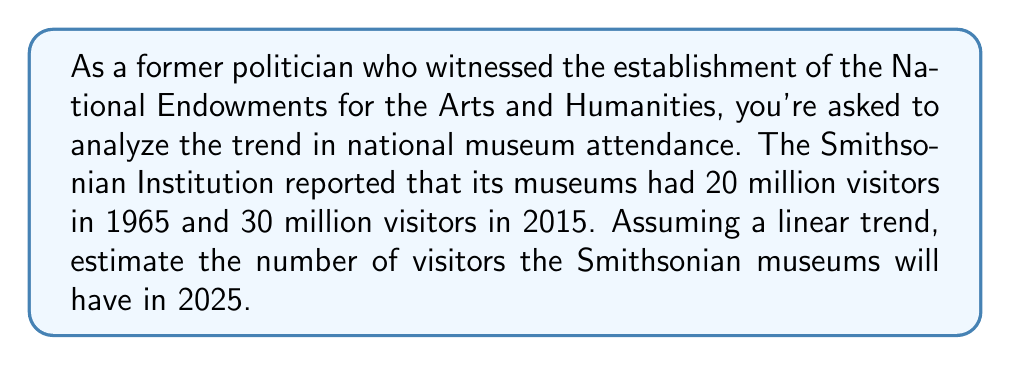Show me your answer to this math problem. To solve this problem, we'll use a linear equation to model the trend in museum attendance over time. Let's follow these steps:

1) Define variables:
   Let $x$ represent the number of years since 1965
   Let $y$ represent the number of visitors in millions

2) Identify two known points:
   (1965, 20): $x_1 = 0$, $y_1 = 20$
   (2015, 30): $x_2 = 50$, $y_2 = 30$

3) Calculate the slope $(m)$ of the line:
   $$m = \frac{y_2 - y_1}{x_2 - x_1} = \frac{30 - 20}{50 - 0} = \frac{10}{50} = 0.2$$

4) Use the point-slope form of a line to create our equation:
   $y - y_1 = m(x - x_1)$
   $y - 20 = 0.2(x - 0)$
   $y = 0.2x + 20$

5) To estimate visitors in 2025, calculate $x$ for 2025:
   2025 - 1965 = 60 years

6) Plug $x = 60$ into our equation:
   $y = 0.2(60) + 20 = 12 + 20 = 32$

Therefore, we estimate that in 2025, the Smithsonian museums will have 32 million visitors.
Answer: 32 million visitors 